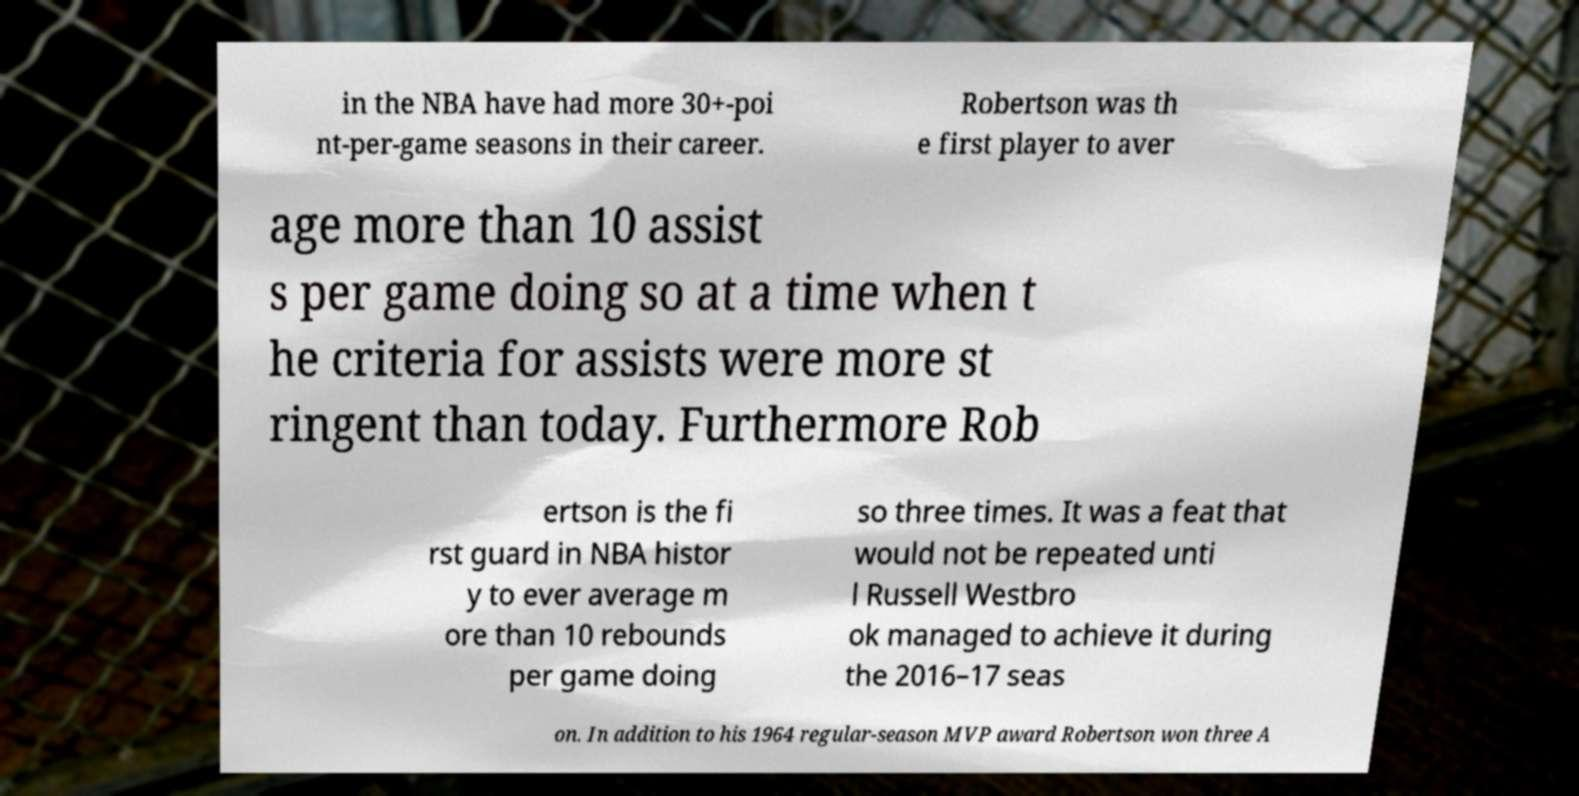There's text embedded in this image that I need extracted. Can you transcribe it verbatim? in the NBA have had more 30+-poi nt-per-game seasons in their career. Robertson was th e first player to aver age more than 10 assist s per game doing so at a time when t he criteria for assists were more st ringent than today. Furthermore Rob ertson is the fi rst guard in NBA histor y to ever average m ore than 10 rebounds per game doing so three times. It was a feat that would not be repeated unti l Russell Westbro ok managed to achieve it during the 2016–17 seas on. In addition to his 1964 regular-season MVP award Robertson won three A 